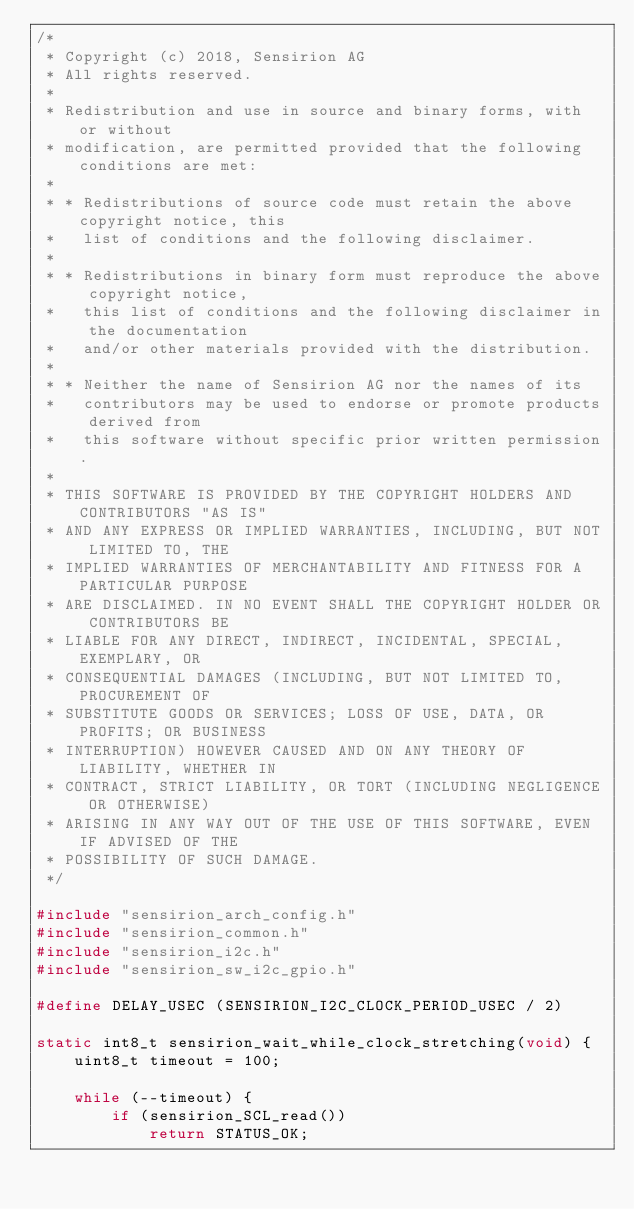Convert code to text. <code><loc_0><loc_0><loc_500><loc_500><_C_>/*
 * Copyright (c) 2018, Sensirion AG
 * All rights reserved.
 *
 * Redistribution and use in source and binary forms, with or without
 * modification, are permitted provided that the following conditions are met:
 *
 * * Redistributions of source code must retain the above copyright notice, this
 *   list of conditions and the following disclaimer.
 *
 * * Redistributions in binary form must reproduce the above copyright notice,
 *   this list of conditions and the following disclaimer in the documentation
 *   and/or other materials provided with the distribution.
 *
 * * Neither the name of Sensirion AG nor the names of its
 *   contributors may be used to endorse or promote products derived from
 *   this software without specific prior written permission.
 *
 * THIS SOFTWARE IS PROVIDED BY THE COPYRIGHT HOLDERS AND CONTRIBUTORS "AS IS"
 * AND ANY EXPRESS OR IMPLIED WARRANTIES, INCLUDING, BUT NOT LIMITED TO, THE
 * IMPLIED WARRANTIES OF MERCHANTABILITY AND FITNESS FOR A PARTICULAR PURPOSE
 * ARE DISCLAIMED. IN NO EVENT SHALL THE COPYRIGHT HOLDER OR CONTRIBUTORS BE
 * LIABLE FOR ANY DIRECT, INDIRECT, INCIDENTAL, SPECIAL, EXEMPLARY, OR
 * CONSEQUENTIAL DAMAGES (INCLUDING, BUT NOT LIMITED TO, PROCUREMENT OF
 * SUBSTITUTE GOODS OR SERVICES; LOSS OF USE, DATA, OR PROFITS; OR BUSINESS
 * INTERRUPTION) HOWEVER CAUSED AND ON ANY THEORY OF LIABILITY, WHETHER IN
 * CONTRACT, STRICT LIABILITY, OR TORT (INCLUDING NEGLIGENCE OR OTHERWISE)
 * ARISING IN ANY WAY OUT OF THE USE OF THIS SOFTWARE, EVEN IF ADVISED OF THE
 * POSSIBILITY OF SUCH DAMAGE.
 */

#include "sensirion_arch_config.h"
#include "sensirion_common.h"
#include "sensirion_i2c.h"
#include "sensirion_sw_i2c_gpio.h"

#define DELAY_USEC (SENSIRION_I2C_CLOCK_PERIOD_USEC / 2)

static int8_t sensirion_wait_while_clock_stretching(void) {
    uint8_t timeout = 100;

    while (--timeout) {
        if (sensirion_SCL_read())
            return STATUS_OK;</code> 